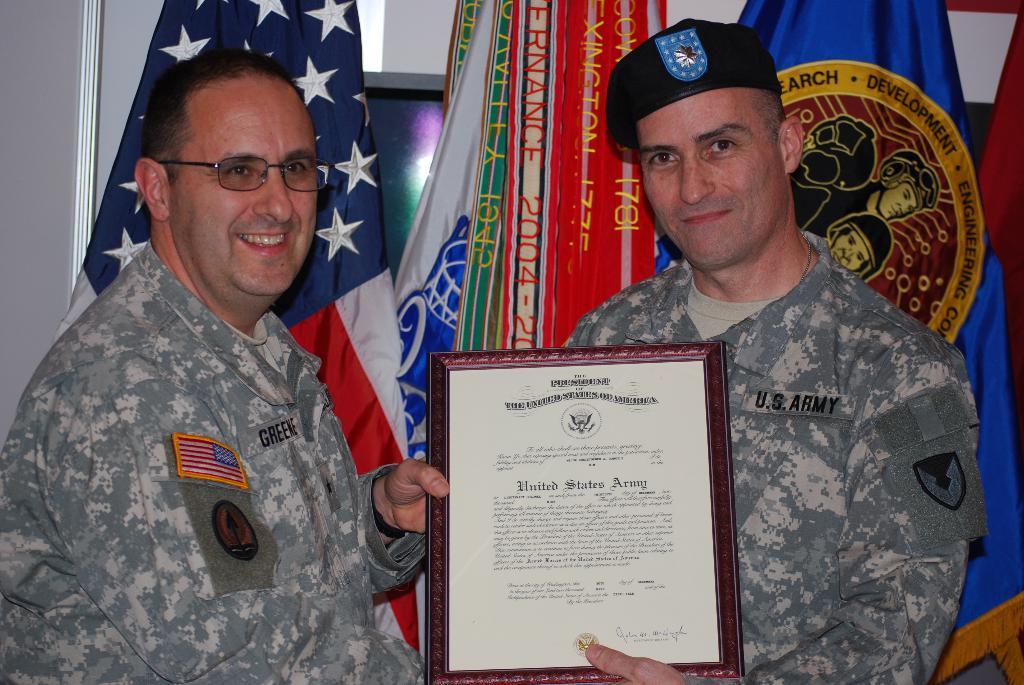Can you describe this image briefly? This image consists of two men there are wearing army dresses and holding a frame. In the background, there are flags. To the left, there is a wall. 